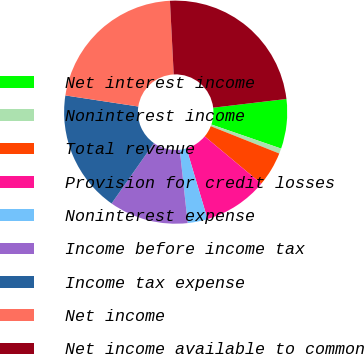Convert chart. <chart><loc_0><loc_0><loc_500><loc_500><pie_chart><fcel>Net interest income<fcel>Noninterest income<fcel>Total revenue<fcel>Provision for credit losses<fcel>Noninterest expense<fcel>Income before income tax<fcel>Income tax expense<fcel>Net income<fcel>Net income available to common<nl><fcel>7.18%<fcel>0.75%<fcel>5.03%<fcel>9.32%<fcel>2.89%<fcel>11.46%<fcel>17.66%<fcel>21.79%<fcel>23.93%<nl></chart> 